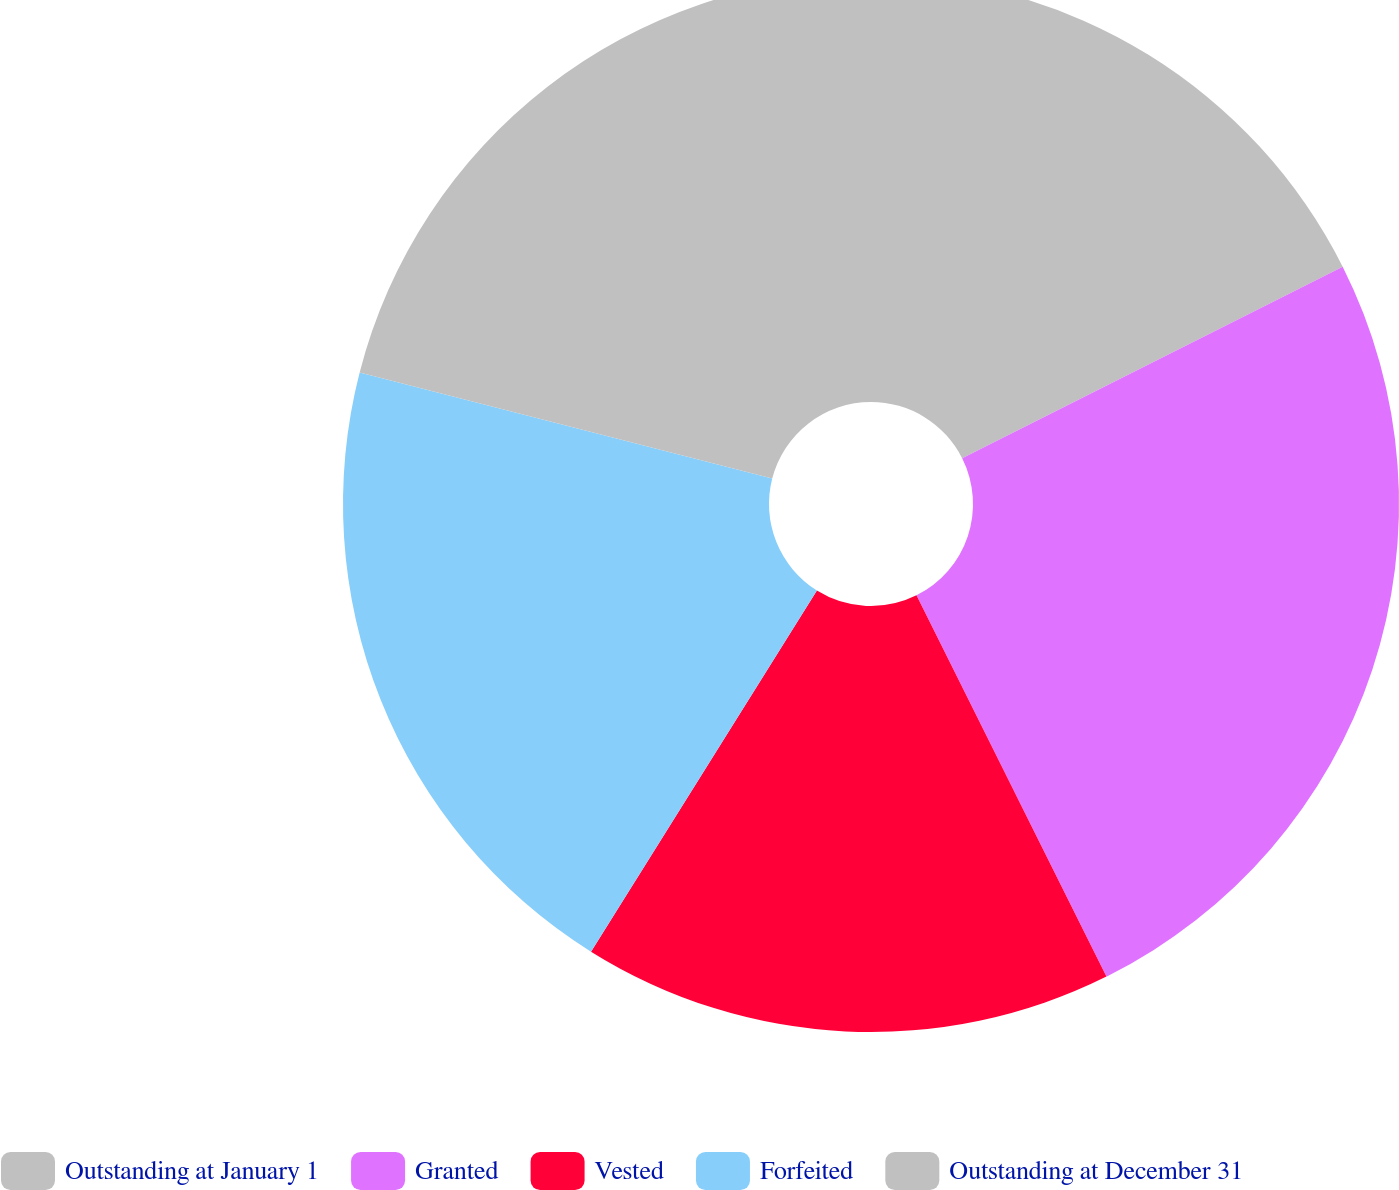Convert chart to OTSL. <chart><loc_0><loc_0><loc_500><loc_500><pie_chart><fcel>Outstanding at January 1<fcel>Granted<fcel>Vested<fcel>Forfeited<fcel>Outstanding at December 31<nl><fcel>17.58%<fcel>25.06%<fcel>16.25%<fcel>20.11%<fcel>20.99%<nl></chart> 